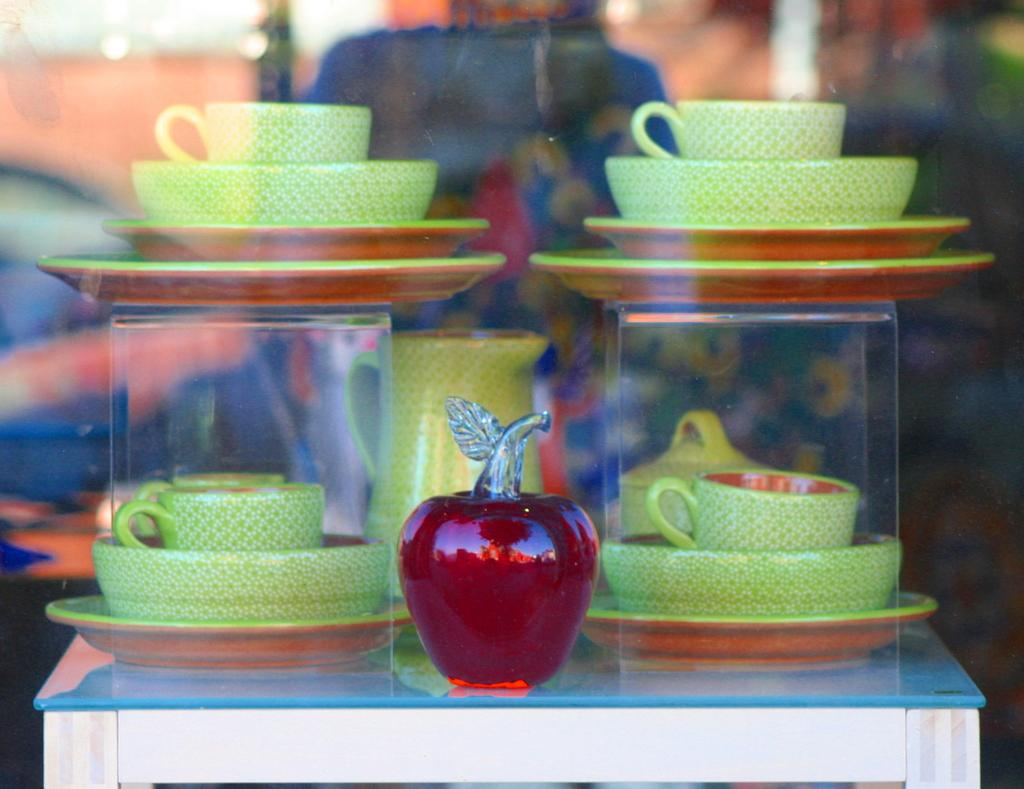What types of tableware are visible in the image? There are cups, bowls, and plates in the image. What other object can be seen on the table in the image? There is a jug on the table in the image. Can you describe the background of the image? The background of the image is blurry. How many cattle can be seen grazing in the image? There are no cattle present in the image. What type of planes are flying in the background of the image? There are no planes visible in the image, and the background is blurry. 